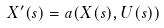<formula> <loc_0><loc_0><loc_500><loc_500>X ^ { \prime } ( s ) = a ( X ( s ) , U ( s ) )</formula> 